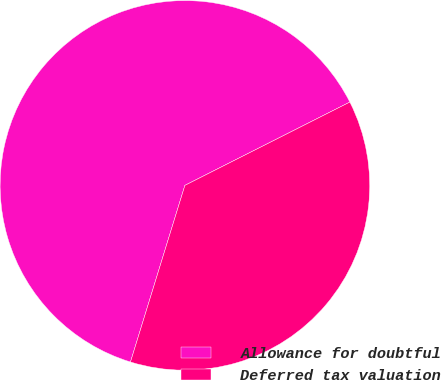Convert chart to OTSL. <chart><loc_0><loc_0><loc_500><loc_500><pie_chart><fcel>Allowance for doubtful<fcel>Deferred tax valuation<nl><fcel>62.8%<fcel>37.2%<nl></chart> 